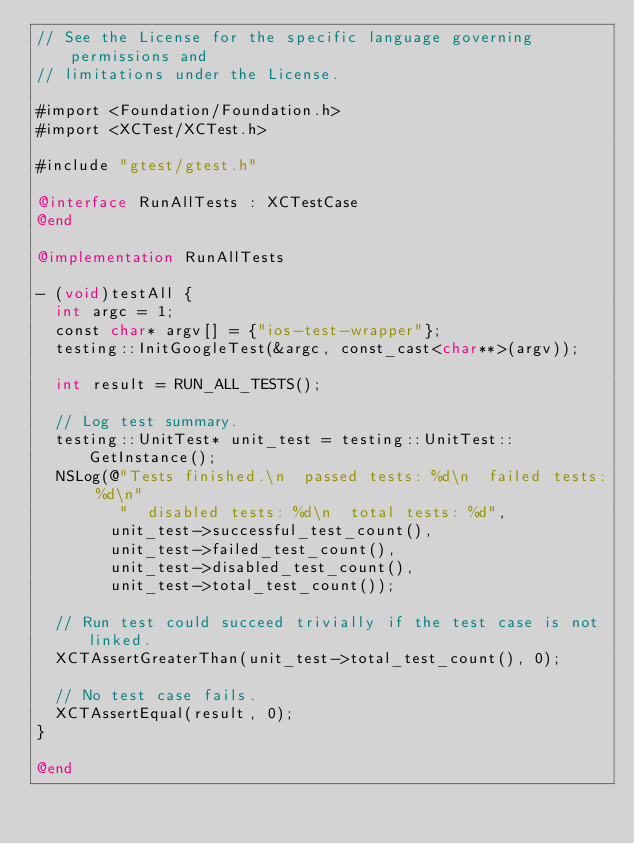Convert code to text. <code><loc_0><loc_0><loc_500><loc_500><_ObjectiveC_>// See the License for the specific language governing permissions and
// limitations under the License.

#import <Foundation/Foundation.h>
#import <XCTest/XCTest.h>

#include "gtest/gtest.h"

@interface RunAllTests : XCTestCase
@end

@implementation RunAllTests

- (void)testAll {
  int argc = 1;
  const char* argv[] = {"ios-test-wrapper"};
  testing::InitGoogleTest(&argc, const_cast<char**>(argv));

  int result = RUN_ALL_TESTS();

  // Log test summary.
  testing::UnitTest* unit_test = testing::UnitTest::GetInstance();
  NSLog(@"Tests finished.\n  passed tests: %d\n  failed tests: %d\n"
         "  disabled tests: %d\n  total tests: %d",
        unit_test->successful_test_count(),
        unit_test->failed_test_count(),
        unit_test->disabled_test_count(),
        unit_test->total_test_count());

  // Run test could succeed trivially if the test case is not linked.
  XCTAssertGreaterThan(unit_test->total_test_count(), 0);

  // No test case fails.
  XCTAssertEqual(result, 0);
}

@end
</code> 